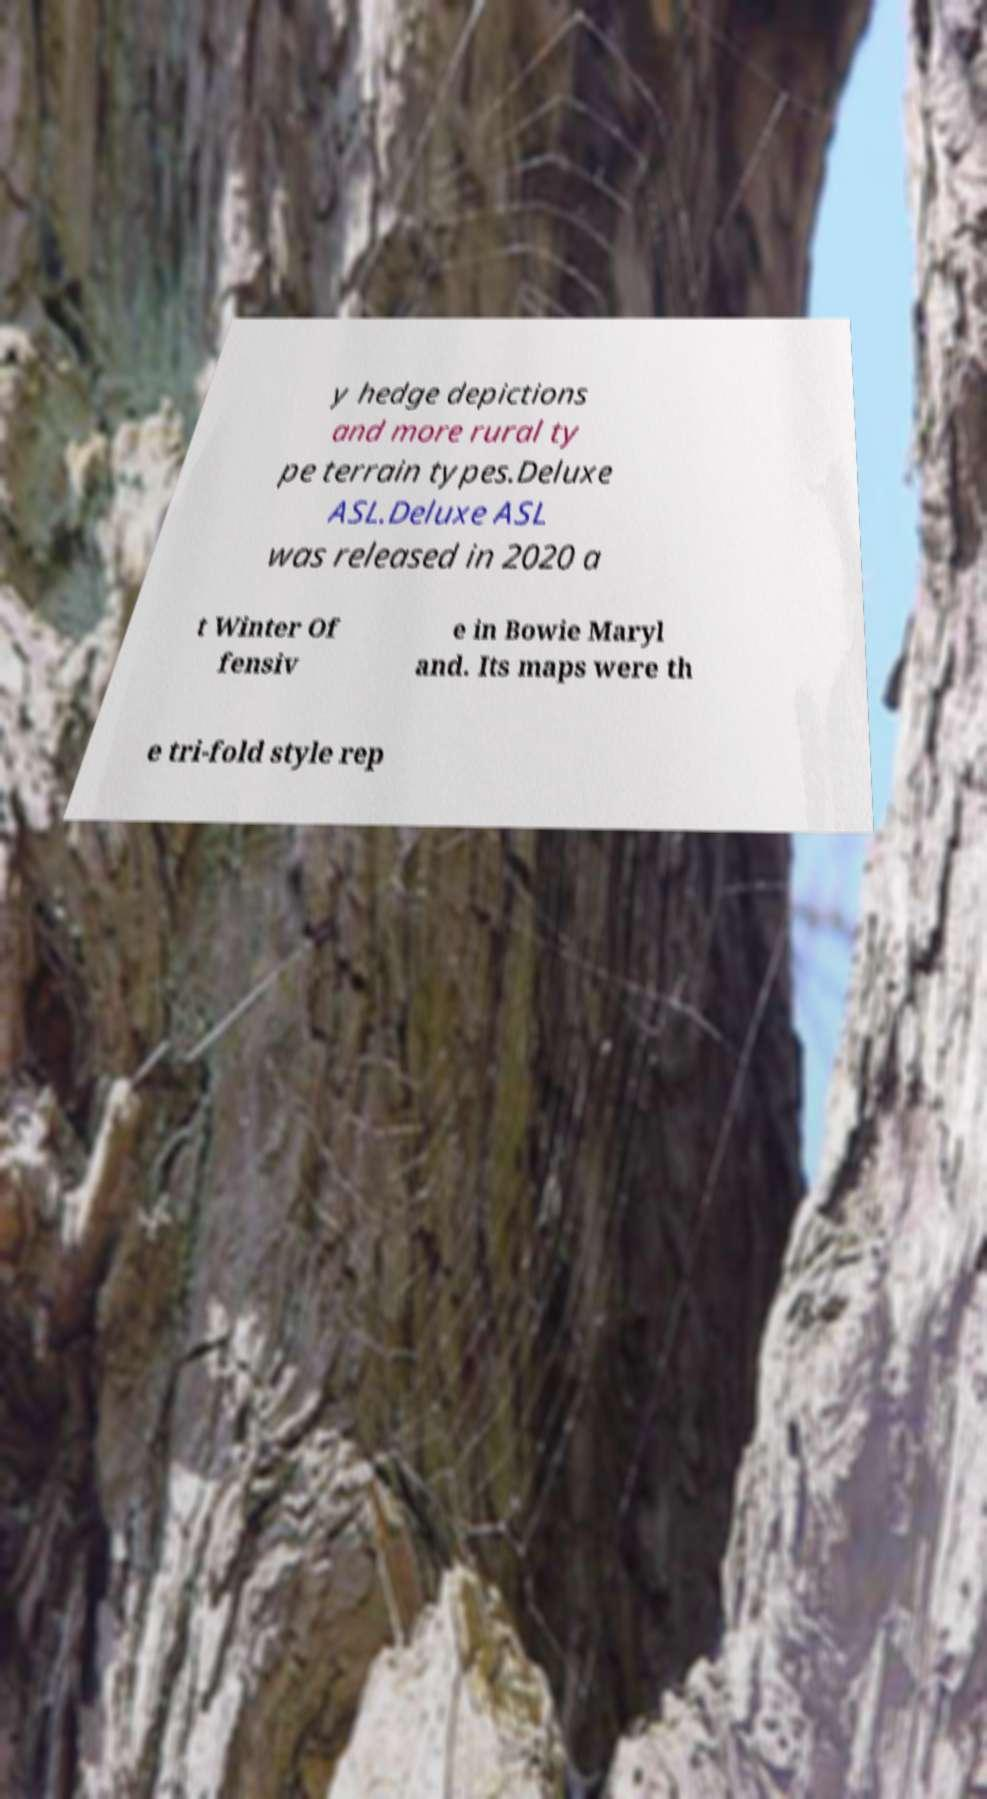Can you read and provide the text displayed in the image?This photo seems to have some interesting text. Can you extract and type it out for me? y hedge depictions and more rural ty pe terrain types.Deluxe ASL.Deluxe ASL was released in 2020 a t Winter Of fensiv e in Bowie Maryl and. Its maps were th e tri-fold style rep 